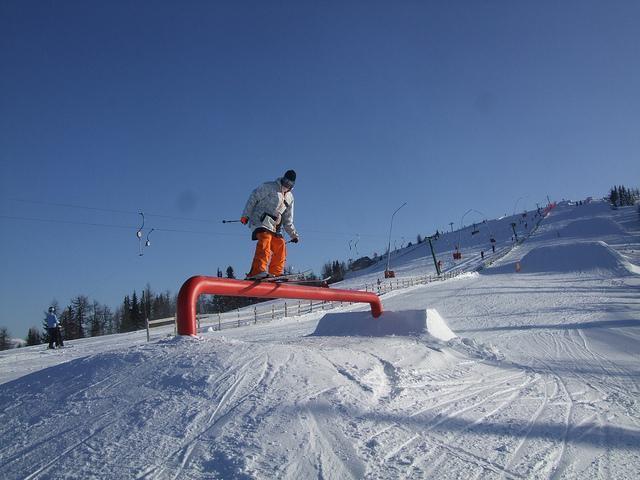What is the man going to do next?
Pick the right solution, then justify: 'Answer: answer
Rationale: rationale.'
Options: Jumping off, flipping over, lying down, sitting down. Answer: jumping off.
Rationale: The skier is beginning to crouch to jump off the rail. 